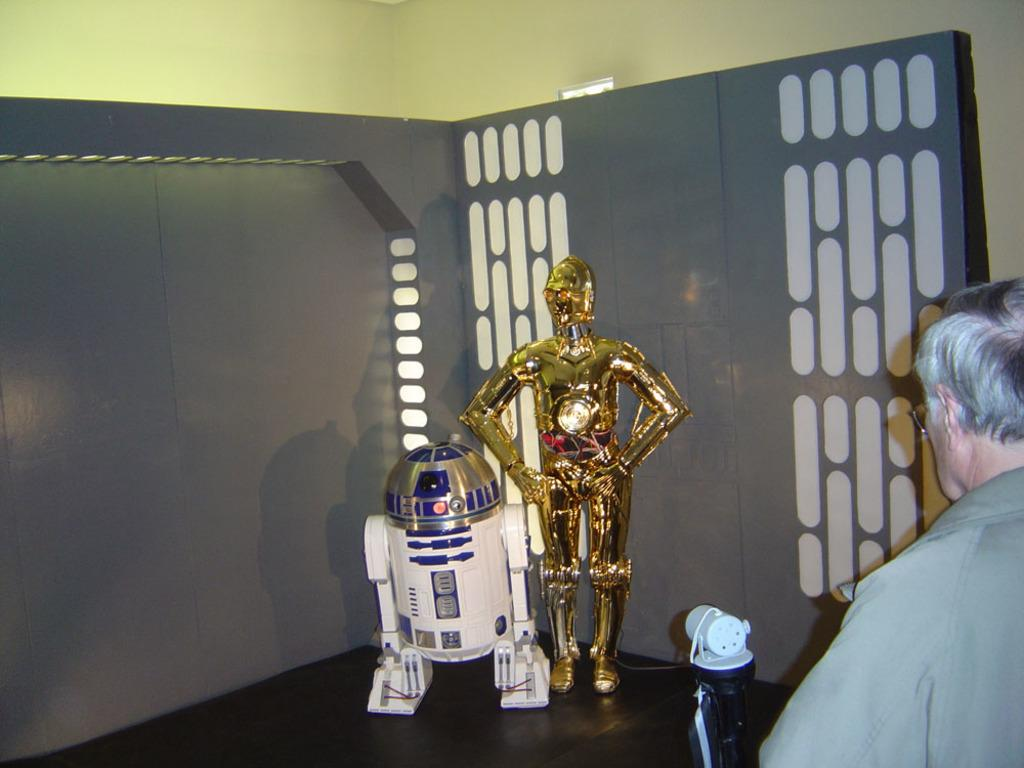What can be seen in the image? There are two robots in the image. What is the man in the image doing? The man is watching the robots. What is visible in the background of the image? There is a wall in the background of the image. What type of cloud can be seen in the image? There is no cloud present in the image; it features two robots and a man watching them. 